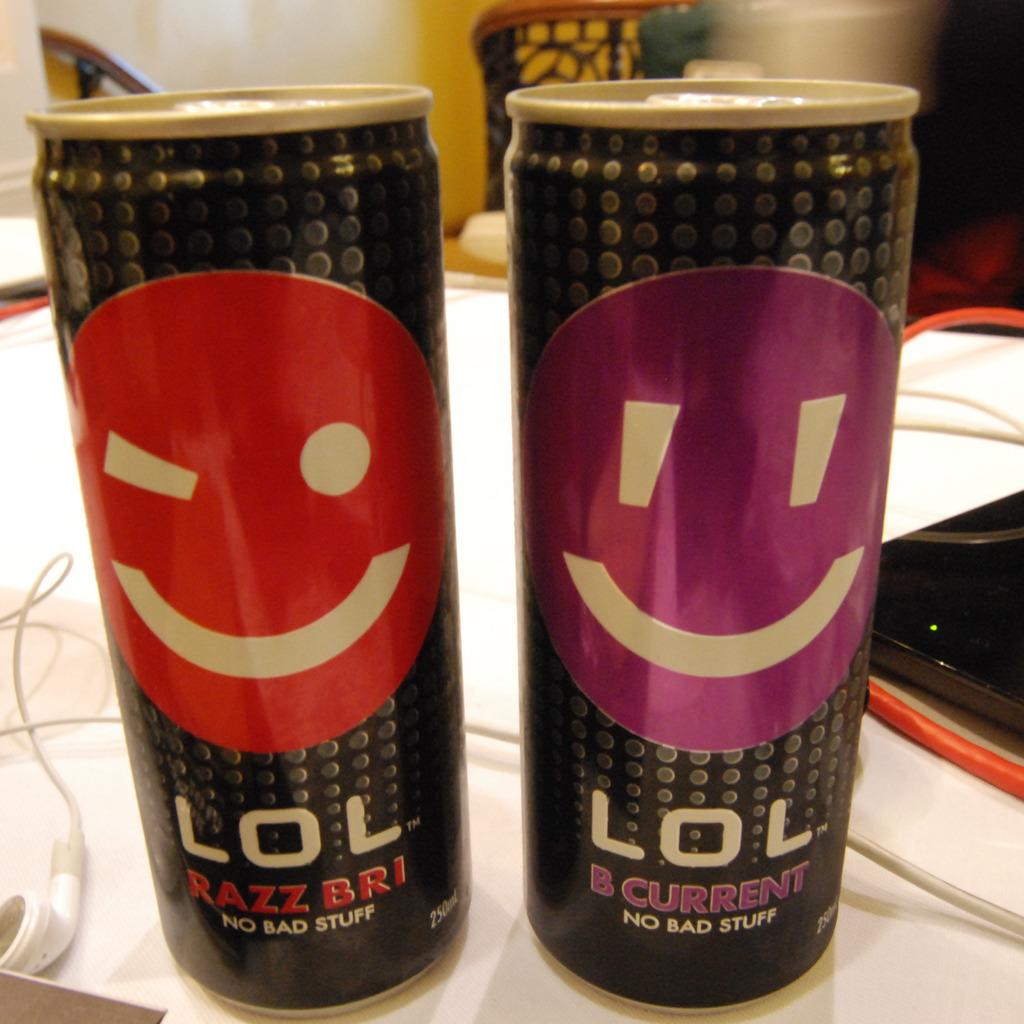What is the name of this drink on the left?
Your answer should be compact. Lol razzbri. What is the name of the drink on the right?
Your response must be concise. Lol b current. 